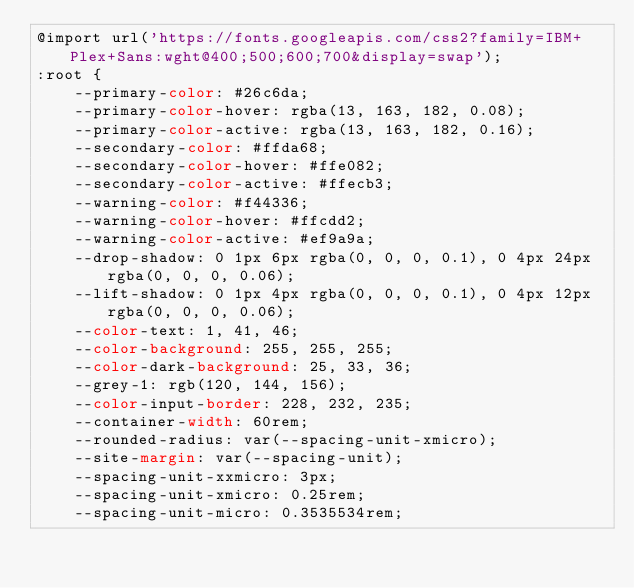<code> <loc_0><loc_0><loc_500><loc_500><_CSS_>@import url('https://fonts.googleapis.com/css2?family=IBM+Plex+Sans:wght@400;500;600;700&display=swap');
:root {
    --primary-color: #26c6da;
    --primary-color-hover: rgba(13, 163, 182, 0.08);
    --primary-color-active: rgba(13, 163, 182, 0.16);
    --secondary-color: #ffda68;
    --secondary-color-hover: #ffe082;
    --secondary-color-active: #ffecb3;
    --warning-color: #f44336;
    --warning-color-hover: #ffcdd2;
    --warning-color-active: #ef9a9a;
    --drop-shadow: 0 1px 6px rgba(0, 0, 0, 0.1), 0 4px 24px rgba(0, 0, 0, 0.06);
    --lift-shadow: 0 1px 4px rgba(0, 0, 0, 0.1), 0 4px 12px rgba(0, 0, 0, 0.06);
    --color-text: 1, 41, 46;
    --color-background: 255, 255, 255;
    --color-dark-background: 25, 33, 36;
    --grey-1: rgb(120, 144, 156);
    --color-input-border: 228, 232, 235;
    --container-width: 60rem;
    --rounded-radius: var(--spacing-unit-xmicro);
    --site-margin: var(--spacing-unit);
    --spacing-unit-xxmicro: 3px;
    --spacing-unit-xmicro: 0.25rem;
    --spacing-unit-micro: 0.3535534rem;</code> 